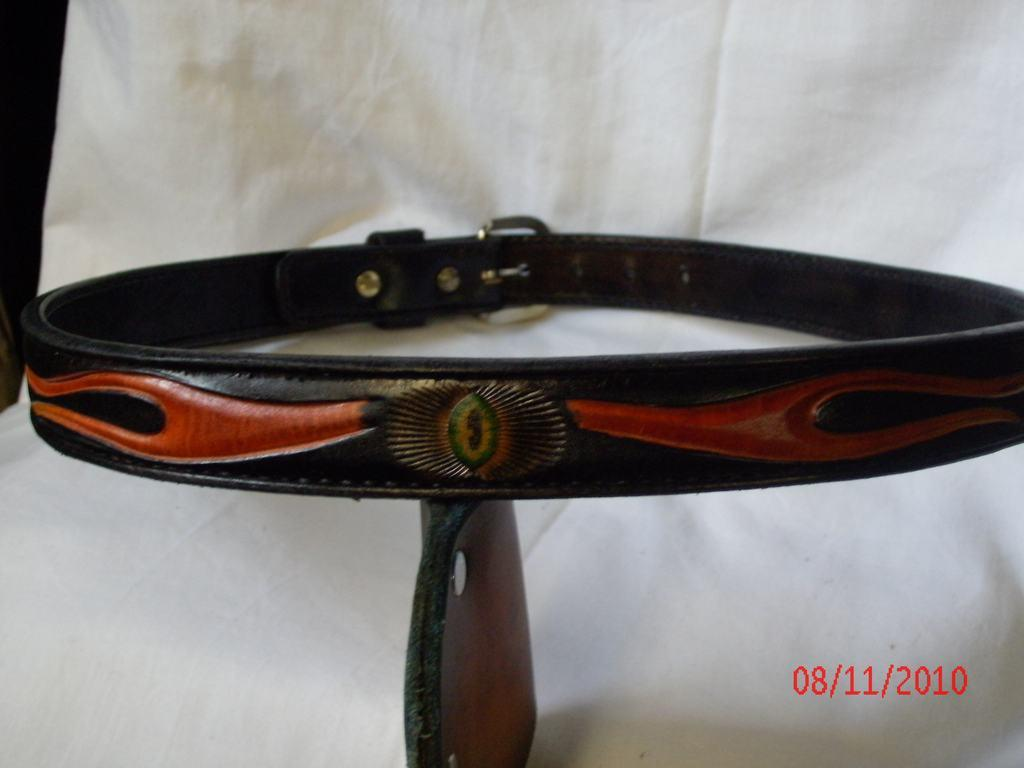What is the main object in the center of the image? There is a belt in the center of the image. What is located at the bottom of the image? There is a cloth at the bottom of the image. What type of instrument is being played in the image? There is no instrument present in the image; it only features a belt and a cloth. What material is the belt made of in the image? The provided facts do not mention the material of the belt, so we cannot determine its composition from the image. 